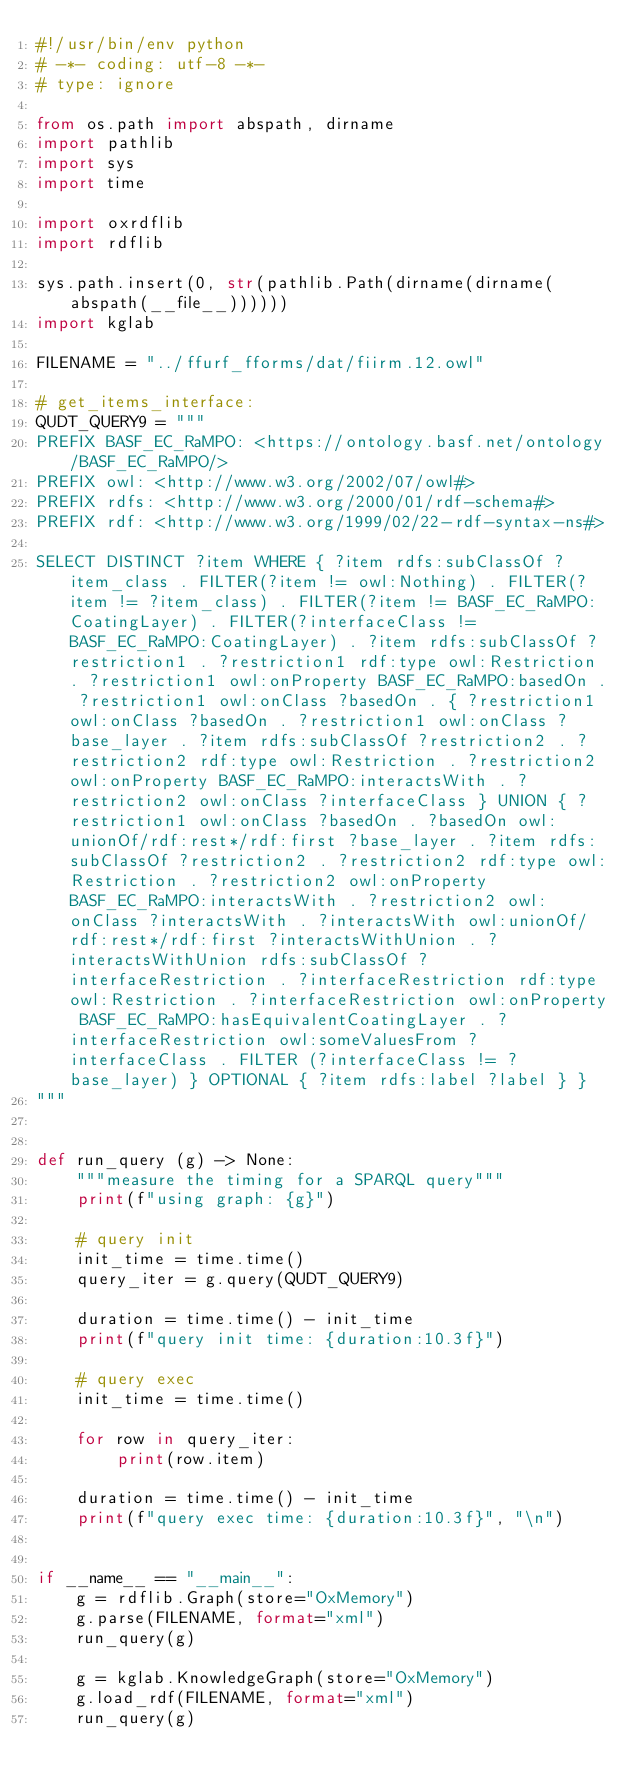Convert code to text. <code><loc_0><loc_0><loc_500><loc_500><_Python_>#!/usr/bin/env python
# -*- coding: utf-8 -*-
# type: ignore

from os.path import abspath, dirname
import pathlib
import sys
import time

import oxrdflib
import rdflib

sys.path.insert(0, str(pathlib.Path(dirname(dirname(abspath(__file__))))))
import kglab

FILENAME = "../ffurf_fforms/dat/fiirm.12.owl"

# get_items_interface:
QUDT_QUERY9 = """
PREFIX BASF_EC_RaMPO: <https://ontology.basf.net/ontology/BASF_EC_RaMPO/>
PREFIX owl: <http://www.w3.org/2002/07/owl#>
PREFIX rdfs: <http://www.w3.org/2000/01/rdf-schema#>
PREFIX rdf: <http://www.w3.org/1999/02/22-rdf-syntax-ns#>

SELECT DISTINCT ?item WHERE { ?item rdfs:subClassOf ?item_class . FILTER(?item != owl:Nothing) . FILTER(?item != ?item_class) . FILTER(?item != BASF_EC_RaMPO:CoatingLayer) . FILTER(?interfaceClass != BASF_EC_RaMPO:CoatingLayer) . ?item rdfs:subClassOf ?restriction1 . ?restriction1 rdf:type owl:Restriction . ?restriction1 owl:onProperty BASF_EC_RaMPO:basedOn . ?restriction1 owl:onClass ?basedOn . { ?restriction1 owl:onClass ?basedOn . ?restriction1 owl:onClass ?base_layer . ?item rdfs:subClassOf ?restriction2 . ?restriction2 rdf:type owl:Restriction . ?restriction2 owl:onProperty BASF_EC_RaMPO:interactsWith . ?restriction2 owl:onClass ?interfaceClass } UNION { ?restriction1 owl:onClass ?basedOn . ?basedOn owl:unionOf/rdf:rest*/rdf:first ?base_layer . ?item rdfs:subClassOf ?restriction2 . ?restriction2 rdf:type owl:Restriction . ?restriction2 owl:onProperty BASF_EC_RaMPO:interactsWith . ?restriction2 owl:onClass ?interactsWith . ?interactsWith owl:unionOf/rdf:rest*/rdf:first ?interactsWithUnion . ?interactsWithUnion rdfs:subClassOf ?interfaceRestriction . ?interfaceRestriction rdf:type owl:Restriction . ?interfaceRestriction owl:onProperty BASF_EC_RaMPO:hasEquivalentCoatingLayer . ?interfaceRestriction owl:someValuesFrom ?interfaceClass . FILTER (?interfaceClass != ?base_layer) } OPTIONAL { ?item rdfs:label ?label } }
"""


def run_query (g) -> None:
    """measure the timing for a SPARQL query"""
    print(f"using graph: {g}")

    # query init
    init_time = time.time()
    query_iter = g.query(QUDT_QUERY9)

    duration = time.time() - init_time
    print(f"query init time: {duration:10.3f}")

    # query exec
    init_time = time.time()

    for row in query_iter:
        print(row.item)

    duration = time.time() - init_time
    print(f"query exec time: {duration:10.3f}", "\n")


if __name__ == "__main__":
    g = rdflib.Graph(store="OxMemory")
    g.parse(FILENAME, format="xml")
    run_query(g)

    g = kglab.KnowledgeGraph(store="OxMemory")
    g.load_rdf(FILENAME, format="xml")
    run_query(g)
</code> 